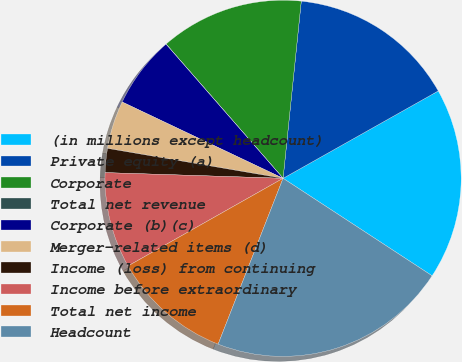<chart> <loc_0><loc_0><loc_500><loc_500><pie_chart><fcel>(in millions except headcount)<fcel>Private equity (a)<fcel>Corporate<fcel>Total net revenue<fcel>Corporate (b)(c)<fcel>Merger-related items (d)<fcel>Income (loss) from continuing<fcel>Income before extraordinary<fcel>Total net income<fcel>Headcount<nl><fcel>17.38%<fcel>15.21%<fcel>13.04%<fcel>0.01%<fcel>6.53%<fcel>4.36%<fcel>2.18%<fcel>8.7%<fcel>10.87%<fcel>21.72%<nl></chart> 